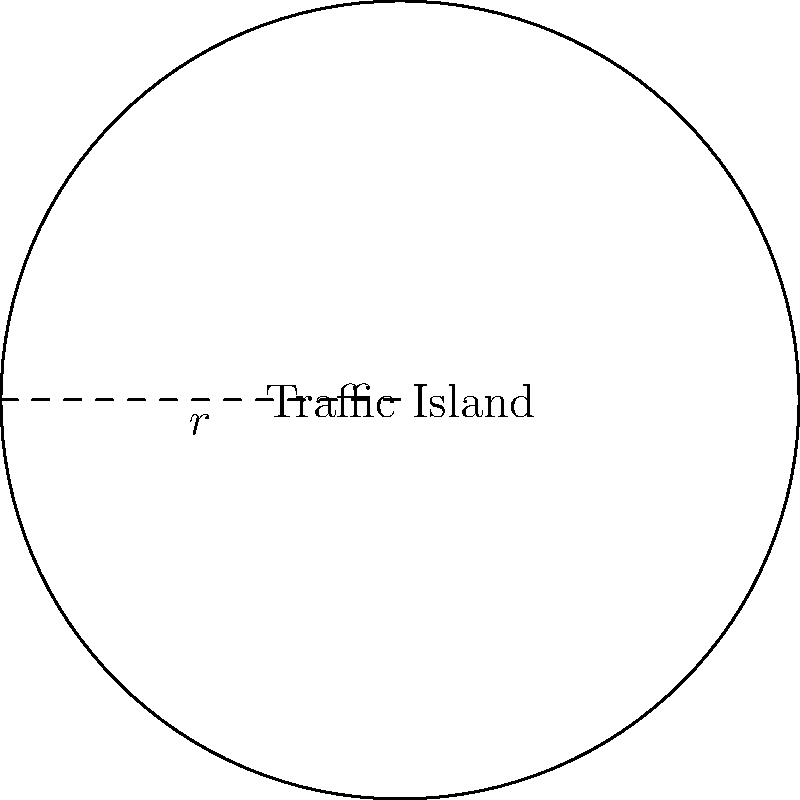A circular traffic island has been proposed to improve pedestrian safety at a busy intersection. If the radius of the island is 5 meters, what is the perimeter of the island? Round your answer to the nearest tenth of a meter. To find the perimeter of a circular traffic island, we need to use the formula for the circumference of a circle:

1. The formula for the circumference of a circle is $C = 2\pi r$, where $r$ is the radius.

2. We are given that the radius is 5 meters.

3. Let's substitute the values into the formula:
   $C = 2\pi \cdot 5$

4. Simplify:
   $C = 10\pi$

5. Calculate the value (using $\pi \approx 3.14159$):
   $C \approx 10 \cdot 3.14159 = 31.4159$ meters

6. Rounding to the nearest tenth:
   $C \approx 31.4$ meters

Therefore, the perimeter of the circular traffic island is approximately 31.4 meters.
Answer: 31.4 meters 